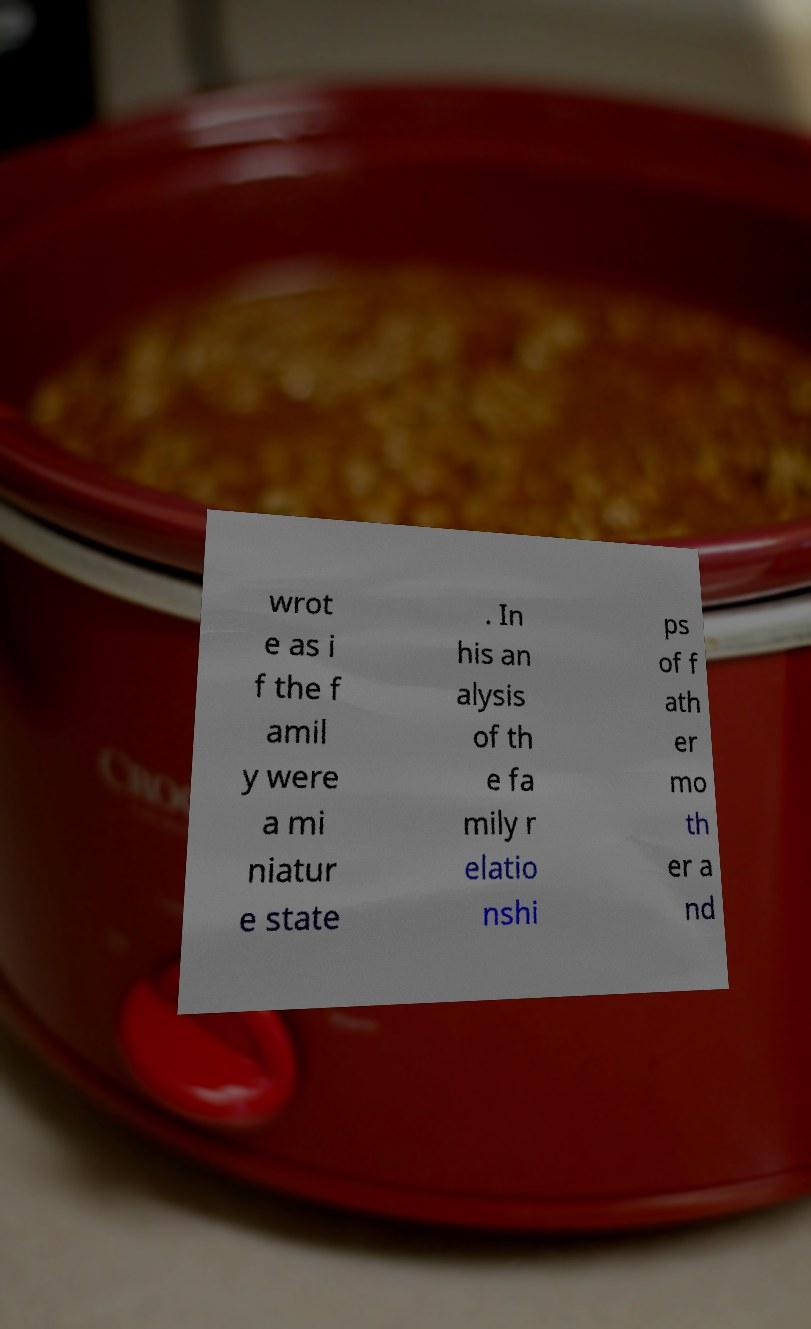Can you read and provide the text displayed in the image?This photo seems to have some interesting text. Can you extract and type it out for me? wrot e as i f the f amil y were a mi niatur e state . In his an alysis of th e fa mily r elatio nshi ps of f ath er mo th er a nd 